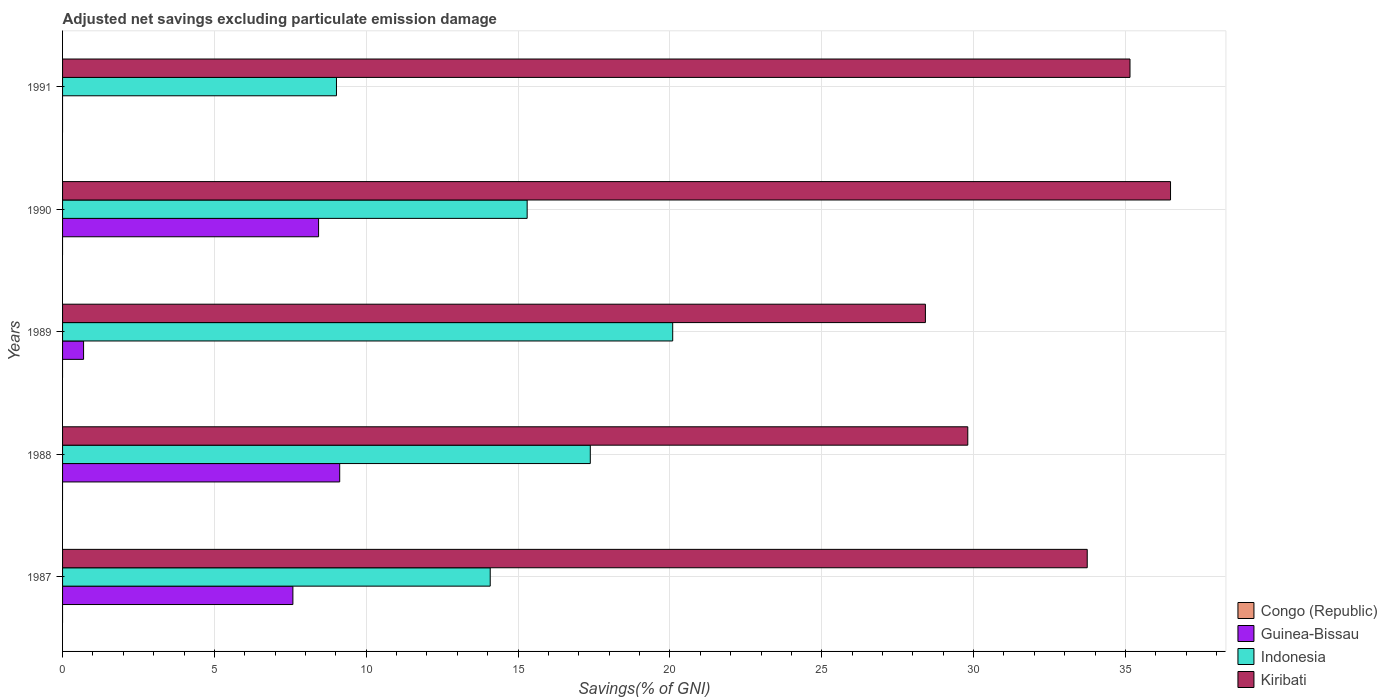Are the number of bars per tick equal to the number of legend labels?
Your answer should be compact. No. Are the number of bars on each tick of the Y-axis equal?
Make the answer very short. No. What is the label of the 1st group of bars from the top?
Provide a succinct answer. 1991. In how many cases, is the number of bars for a given year not equal to the number of legend labels?
Offer a terse response. 5. What is the adjusted net savings in Kiribati in 1988?
Make the answer very short. 29.81. Across all years, what is the maximum adjusted net savings in Guinea-Bissau?
Your answer should be compact. 9.13. Across all years, what is the minimum adjusted net savings in Guinea-Bissau?
Provide a succinct answer. 0. What is the total adjusted net savings in Kiribati in the graph?
Your answer should be very brief. 163.6. What is the difference between the adjusted net savings in Kiribati in 1988 and that in 1990?
Your answer should be compact. -6.68. What is the difference between the adjusted net savings in Indonesia in 1990 and the adjusted net savings in Kiribati in 1991?
Offer a terse response. -19.85. What is the average adjusted net savings in Guinea-Bissau per year?
Offer a terse response. 5.17. In the year 1987, what is the difference between the adjusted net savings in Indonesia and adjusted net savings in Guinea-Bissau?
Keep it short and to the point. 6.5. What is the ratio of the adjusted net savings in Indonesia in 1988 to that in 1990?
Offer a very short reply. 1.14. Is the difference between the adjusted net savings in Indonesia in 1988 and 1989 greater than the difference between the adjusted net savings in Guinea-Bissau in 1988 and 1989?
Provide a short and direct response. No. What is the difference between the highest and the second highest adjusted net savings in Kiribati?
Keep it short and to the point. 1.33. What is the difference between the highest and the lowest adjusted net savings in Guinea-Bissau?
Provide a succinct answer. 9.13. Is the sum of the adjusted net savings in Kiribati in 1989 and 1991 greater than the maximum adjusted net savings in Guinea-Bissau across all years?
Your answer should be very brief. Yes. Is it the case that in every year, the sum of the adjusted net savings in Kiribati and adjusted net savings in Guinea-Bissau is greater than the sum of adjusted net savings in Congo (Republic) and adjusted net savings in Indonesia?
Keep it short and to the point. Yes. How many bars are there?
Make the answer very short. 14. Are all the bars in the graph horizontal?
Provide a succinct answer. Yes. Does the graph contain any zero values?
Your answer should be very brief. Yes. How many legend labels are there?
Your answer should be very brief. 4. How are the legend labels stacked?
Your response must be concise. Vertical. What is the title of the graph?
Your response must be concise. Adjusted net savings excluding particulate emission damage. Does "Grenada" appear as one of the legend labels in the graph?
Give a very brief answer. No. What is the label or title of the X-axis?
Give a very brief answer. Savings(% of GNI). What is the Savings(% of GNI) in Guinea-Bissau in 1987?
Offer a very short reply. 7.58. What is the Savings(% of GNI) of Indonesia in 1987?
Your answer should be compact. 14.08. What is the Savings(% of GNI) in Kiribati in 1987?
Your answer should be compact. 33.74. What is the Savings(% of GNI) in Guinea-Bissau in 1988?
Offer a very short reply. 9.13. What is the Savings(% of GNI) of Indonesia in 1988?
Give a very brief answer. 17.38. What is the Savings(% of GNI) in Kiribati in 1988?
Make the answer very short. 29.81. What is the Savings(% of GNI) of Guinea-Bissau in 1989?
Provide a short and direct response. 0.69. What is the Savings(% of GNI) in Indonesia in 1989?
Provide a short and direct response. 20.09. What is the Savings(% of GNI) of Kiribati in 1989?
Keep it short and to the point. 28.41. What is the Savings(% of GNI) of Guinea-Bissau in 1990?
Provide a short and direct response. 8.43. What is the Savings(% of GNI) of Indonesia in 1990?
Offer a terse response. 15.3. What is the Savings(% of GNI) of Kiribati in 1990?
Provide a succinct answer. 36.49. What is the Savings(% of GNI) of Guinea-Bissau in 1991?
Your answer should be compact. 0. What is the Savings(% of GNI) of Indonesia in 1991?
Keep it short and to the point. 9.02. What is the Savings(% of GNI) of Kiribati in 1991?
Give a very brief answer. 35.15. Across all years, what is the maximum Savings(% of GNI) of Guinea-Bissau?
Your response must be concise. 9.13. Across all years, what is the maximum Savings(% of GNI) in Indonesia?
Your response must be concise. 20.09. Across all years, what is the maximum Savings(% of GNI) of Kiribati?
Make the answer very short. 36.49. Across all years, what is the minimum Savings(% of GNI) in Guinea-Bissau?
Give a very brief answer. 0. Across all years, what is the minimum Savings(% of GNI) in Indonesia?
Make the answer very short. 9.02. Across all years, what is the minimum Savings(% of GNI) of Kiribati?
Ensure brevity in your answer.  28.41. What is the total Savings(% of GNI) in Guinea-Bissau in the graph?
Make the answer very short. 25.83. What is the total Savings(% of GNI) in Indonesia in the graph?
Ensure brevity in your answer.  75.87. What is the total Savings(% of GNI) in Kiribati in the graph?
Your answer should be compact. 163.6. What is the difference between the Savings(% of GNI) in Guinea-Bissau in 1987 and that in 1988?
Keep it short and to the point. -1.54. What is the difference between the Savings(% of GNI) in Indonesia in 1987 and that in 1988?
Offer a terse response. -3.3. What is the difference between the Savings(% of GNI) in Kiribati in 1987 and that in 1988?
Make the answer very short. 3.93. What is the difference between the Savings(% of GNI) of Guinea-Bissau in 1987 and that in 1989?
Offer a terse response. 6.89. What is the difference between the Savings(% of GNI) in Indonesia in 1987 and that in 1989?
Offer a terse response. -6.01. What is the difference between the Savings(% of GNI) of Kiribati in 1987 and that in 1989?
Offer a very short reply. 5.33. What is the difference between the Savings(% of GNI) of Guinea-Bissau in 1987 and that in 1990?
Your answer should be compact. -0.85. What is the difference between the Savings(% of GNI) in Indonesia in 1987 and that in 1990?
Provide a succinct answer. -1.22. What is the difference between the Savings(% of GNI) in Kiribati in 1987 and that in 1990?
Your answer should be compact. -2.74. What is the difference between the Savings(% of GNI) in Indonesia in 1987 and that in 1991?
Offer a terse response. 5.06. What is the difference between the Savings(% of GNI) in Kiribati in 1987 and that in 1991?
Offer a terse response. -1.41. What is the difference between the Savings(% of GNI) of Guinea-Bissau in 1988 and that in 1989?
Your answer should be very brief. 8.43. What is the difference between the Savings(% of GNI) in Indonesia in 1988 and that in 1989?
Your response must be concise. -2.71. What is the difference between the Savings(% of GNI) of Kiribati in 1988 and that in 1989?
Ensure brevity in your answer.  1.4. What is the difference between the Savings(% of GNI) in Guinea-Bissau in 1988 and that in 1990?
Offer a terse response. 0.7. What is the difference between the Savings(% of GNI) of Indonesia in 1988 and that in 1990?
Offer a very short reply. 2.08. What is the difference between the Savings(% of GNI) in Kiribati in 1988 and that in 1990?
Provide a succinct answer. -6.68. What is the difference between the Savings(% of GNI) in Indonesia in 1988 and that in 1991?
Offer a terse response. 8.36. What is the difference between the Savings(% of GNI) in Kiribati in 1988 and that in 1991?
Your answer should be compact. -5.34. What is the difference between the Savings(% of GNI) of Guinea-Bissau in 1989 and that in 1990?
Your answer should be compact. -7.74. What is the difference between the Savings(% of GNI) of Indonesia in 1989 and that in 1990?
Your answer should be compact. 4.79. What is the difference between the Savings(% of GNI) of Kiribati in 1989 and that in 1990?
Provide a short and direct response. -8.07. What is the difference between the Savings(% of GNI) in Indonesia in 1989 and that in 1991?
Ensure brevity in your answer.  11.07. What is the difference between the Savings(% of GNI) in Kiribati in 1989 and that in 1991?
Offer a very short reply. -6.74. What is the difference between the Savings(% of GNI) of Indonesia in 1990 and that in 1991?
Offer a very short reply. 6.28. What is the difference between the Savings(% of GNI) of Kiribati in 1990 and that in 1991?
Provide a short and direct response. 1.33. What is the difference between the Savings(% of GNI) of Guinea-Bissau in 1987 and the Savings(% of GNI) of Indonesia in 1988?
Your answer should be compact. -9.79. What is the difference between the Savings(% of GNI) of Guinea-Bissau in 1987 and the Savings(% of GNI) of Kiribati in 1988?
Your answer should be very brief. -22.22. What is the difference between the Savings(% of GNI) in Indonesia in 1987 and the Savings(% of GNI) in Kiribati in 1988?
Ensure brevity in your answer.  -15.73. What is the difference between the Savings(% of GNI) of Guinea-Bissau in 1987 and the Savings(% of GNI) of Indonesia in 1989?
Provide a short and direct response. -12.51. What is the difference between the Savings(% of GNI) of Guinea-Bissau in 1987 and the Savings(% of GNI) of Kiribati in 1989?
Keep it short and to the point. -20.83. What is the difference between the Savings(% of GNI) in Indonesia in 1987 and the Savings(% of GNI) in Kiribati in 1989?
Your answer should be very brief. -14.33. What is the difference between the Savings(% of GNI) in Guinea-Bissau in 1987 and the Savings(% of GNI) in Indonesia in 1990?
Provide a short and direct response. -7.71. What is the difference between the Savings(% of GNI) in Guinea-Bissau in 1987 and the Savings(% of GNI) in Kiribati in 1990?
Make the answer very short. -28.9. What is the difference between the Savings(% of GNI) in Indonesia in 1987 and the Savings(% of GNI) in Kiribati in 1990?
Your response must be concise. -22.4. What is the difference between the Savings(% of GNI) of Guinea-Bissau in 1987 and the Savings(% of GNI) of Indonesia in 1991?
Provide a succinct answer. -1.43. What is the difference between the Savings(% of GNI) in Guinea-Bissau in 1987 and the Savings(% of GNI) in Kiribati in 1991?
Keep it short and to the point. -27.57. What is the difference between the Savings(% of GNI) of Indonesia in 1987 and the Savings(% of GNI) of Kiribati in 1991?
Your answer should be very brief. -21.07. What is the difference between the Savings(% of GNI) in Guinea-Bissau in 1988 and the Savings(% of GNI) in Indonesia in 1989?
Your response must be concise. -10.97. What is the difference between the Savings(% of GNI) of Guinea-Bissau in 1988 and the Savings(% of GNI) of Kiribati in 1989?
Your answer should be compact. -19.29. What is the difference between the Savings(% of GNI) in Indonesia in 1988 and the Savings(% of GNI) in Kiribati in 1989?
Keep it short and to the point. -11.03. What is the difference between the Savings(% of GNI) of Guinea-Bissau in 1988 and the Savings(% of GNI) of Indonesia in 1990?
Your response must be concise. -6.17. What is the difference between the Savings(% of GNI) of Guinea-Bissau in 1988 and the Savings(% of GNI) of Kiribati in 1990?
Ensure brevity in your answer.  -27.36. What is the difference between the Savings(% of GNI) of Indonesia in 1988 and the Savings(% of GNI) of Kiribati in 1990?
Offer a very short reply. -19.11. What is the difference between the Savings(% of GNI) of Guinea-Bissau in 1988 and the Savings(% of GNI) of Indonesia in 1991?
Provide a short and direct response. 0.11. What is the difference between the Savings(% of GNI) in Guinea-Bissau in 1988 and the Savings(% of GNI) in Kiribati in 1991?
Provide a short and direct response. -26.02. What is the difference between the Savings(% of GNI) of Indonesia in 1988 and the Savings(% of GNI) of Kiribati in 1991?
Provide a succinct answer. -17.77. What is the difference between the Savings(% of GNI) of Guinea-Bissau in 1989 and the Savings(% of GNI) of Indonesia in 1990?
Your response must be concise. -14.61. What is the difference between the Savings(% of GNI) in Guinea-Bissau in 1989 and the Savings(% of GNI) in Kiribati in 1990?
Make the answer very short. -35.79. What is the difference between the Savings(% of GNI) of Indonesia in 1989 and the Savings(% of GNI) of Kiribati in 1990?
Your answer should be very brief. -16.39. What is the difference between the Savings(% of GNI) in Guinea-Bissau in 1989 and the Savings(% of GNI) in Indonesia in 1991?
Your answer should be compact. -8.33. What is the difference between the Savings(% of GNI) of Guinea-Bissau in 1989 and the Savings(% of GNI) of Kiribati in 1991?
Provide a succinct answer. -34.46. What is the difference between the Savings(% of GNI) of Indonesia in 1989 and the Savings(% of GNI) of Kiribati in 1991?
Keep it short and to the point. -15.06. What is the difference between the Savings(% of GNI) in Guinea-Bissau in 1990 and the Savings(% of GNI) in Indonesia in 1991?
Ensure brevity in your answer.  -0.59. What is the difference between the Savings(% of GNI) in Guinea-Bissau in 1990 and the Savings(% of GNI) in Kiribati in 1991?
Give a very brief answer. -26.72. What is the difference between the Savings(% of GNI) in Indonesia in 1990 and the Savings(% of GNI) in Kiribati in 1991?
Your answer should be very brief. -19.85. What is the average Savings(% of GNI) in Guinea-Bissau per year?
Provide a short and direct response. 5.17. What is the average Savings(% of GNI) in Indonesia per year?
Provide a short and direct response. 15.17. What is the average Savings(% of GNI) of Kiribati per year?
Offer a very short reply. 32.72. In the year 1987, what is the difference between the Savings(% of GNI) of Guinea-Bissau and Savings(% of GNI) of Indonesia?
Make the answer very short. -6.5. In the year 1987, what is the difference between the Savings(% of GNI) of Guinea-Bissau and Savings(% of GNI) of Kiribati?
Offer a very short reply. -26.16. In the year 1987, what is the difference between the Savings(% of GNI) in Indonesia and Savings(% of GNI) in Kiribati?
Provide a short and direct response. -19.66. In the year 1988, what is the difference between the Savings(% of GNI) in Guinea-Bissau and Savings(% of GNI) in Indonesia?
Provide a short and direct response. -8.25. In the year 1988, what is the difference between the Savings(% of GNI) in Guinea-Bissau and Savings(% of GNI) in Kiribati?
Provide a short and direct response. -20.68. In the year 1988, what is the difference between the Savings(% of GNI) of Indonesia and Savings(% of GNI) of Kiribati?
Your response must be concise. -12.43. In the year 1989, what is the difference between the Savings(% of GNI) of Guinea-Bissau and Savings(% of GNI) of Indonesia?
Your answer should be compact. -19.4. In the year 1989, what is the difference between the Savings(% of GNI) of Guinea-Bissau and Savings(% of GNI) of Kiribati?
Your answer should be compact. -27.72. In the year 1989, what is the difference between the Savings(% of GNI) of Indonesia and Savings(% of GNI) of Kiribati?
Your answer should be compact. -8.32. In the year 1990, what is the difference between the Savings(% of GNI) in Guinea-Bissau and Savings(% of GNI) in Indonesia?
Make the answer very short. -6.87. In the year 1990, what is the difference between the Savings(% of GNI) in Guinea-Bissau and Savings(% of GNI) in Kiribati?
Give a very brief answer. -28.05. In the year 1990, what is the difference between the Savings(% of GNI) in Indonesia and Savings(% of GNI) in Kiribati?
Ensure brevity in your answer.  -21.19. In the year 1991, what is the difference between the Savings(% of GNI) in Indonesia and Savings(% of GNI) in Kiribati?
Your response must be concise. -26.13. What is the ratio of the Savings(% of GNI) of Guinea-Bissau in 1987 to that in 1988?
Give a very brief answer. 0.83. What is the ratio of the Savings(% of GNI) in Indonesia in 1987 to that in 1988?
Provide a succinct answer. 0.81. What is the ratio of the Savings(% of GNI) in Kiribati in 1987 to that in 1988?
Offer a terse response. 1.13. What is the ratio of the Savings(% of GNI) of Guinea-Bissau in 1987 to that in 1989?
Your answer should be very brief. 10.96. What is the ratio of the Savings(% of GNI) of Indonesia in 1987 to that in 1989?
Your response must be concise. 0.7. What is the ratio of the Savings(% of GNI) of Kiribati in 1987 to that in 1989?
Ensure brevity in your answer.  1.19. What is the ratio of the Savings(% of GNI) of Guinea-Bissau in 1987 to that in 1990?
Offer a terse response. 0.9. What is the ratio of the Savings(% of GNI) of Indonesia in 1987 to that in 1990?
Keep it short and to the point. 0.92. What is the ratio of the Savings(% of GNI) in Kiribati in 1987 to that in 1990?
Provide a short and direct response. 0.92. What is the ratio of the Savings(% of GNI) of Indonesia in 1987 to that in 1991?
Keep it short and to the point. 1.56. What is the ratio of the Savings(% of GNI) in Kiribati in 1987 to that in 1991?
Ensure brevity in your answer.  0.96. What is the ratio of the Savings(% of GNI) of Guinea-Bissau in 1988 to that in 1989?
Your answer should be compact. 13.19. What is the ratio of the Savings(% of GNI) of Indonesia in 1988 to that in 1989?
Provide a short and direct response. 0.86. What is the ratio of the Savings(% of GNI) of Kiribati in 1988 to that in 1989?
Make the answer very short. 1.05. What is the ratio of the Savings(% of GNI) in Guinea-Bissau in 1988 to that in 1990?
Your response must be concise. 1.08. What is the ratio of the Savings(% of GNI) in Indonesia in 1988 to that in 1990?
Provide a succinct answer. 1.14. What is the ratio of the Savings(% of GNI) of Kiribati in 1988 to that in 1990?
Offer a very short reply. 0.82. What is the ratio of the Savings(% of GNI) of Indonesia in 1988 to that in 1991?
Provide a succinct answer. 1.93. What is the ratio of the Savings(% of GNI) of Kiribati in 1988 to that in 1991?
Give a very brief answer. 0.85. What is the ratio of the Savings(% of GNI) in Guinea-Bissau in 1989 to that in 1990?
Give a very brief answer. 0.08. What is the ratio of the Savings(% of GNI) of Indonesia in 1989 to that in 1990?
Make the answer very short. 1.31. What is the ratio of the Savings(% of GNI) in Kiribati in 1989 to that in 1990?
Give a very brief answer. 0.78. What is the ratio of the Savings(% of GNI) in Indonesia in 1989 to that in 1991?
Your answer should be compact. 2.23. What is the ratio of the Savings(% of GNI) in Kiribati in 1989 to that in 1991?
Give a very brief answer. 0.81. What is the ratio of the Savings(% of GNI) of Indonesia in 1990 to that in 1991?
Ensure brevity in your answer.  1.7. What is the ratio of the Savings(% of GNI) of Kiribati in 1990 to that in 1991?
Make the answer very short. 1.04. What is the difference between the highest and the second highest Savings(% of GNI) of Guinea-Bissau?
Keep it short and to the point. 0.7. What is the difference between the highest and the second highest Savings(% of GNI) of Indonesia?
Make the answer very short. 2.71. What is the difference between the highest and the second highest Savings(% of GNI) in Kiribati?
Give a very brief answer. 1.33. What is the difference between the highest and the lowest Savings(% of GNI) in Guinea-Bissau?
Your answer should be compact. 9.13. What is the difference between the highest and the lowest Savings(% of GNI) in Indonesia?
Ensure brevity in your answer.  11.07. What is the difference between the highest and the lowest Savings(% of GNI) of Kiribati?
Make the answer very short. 8.07. 